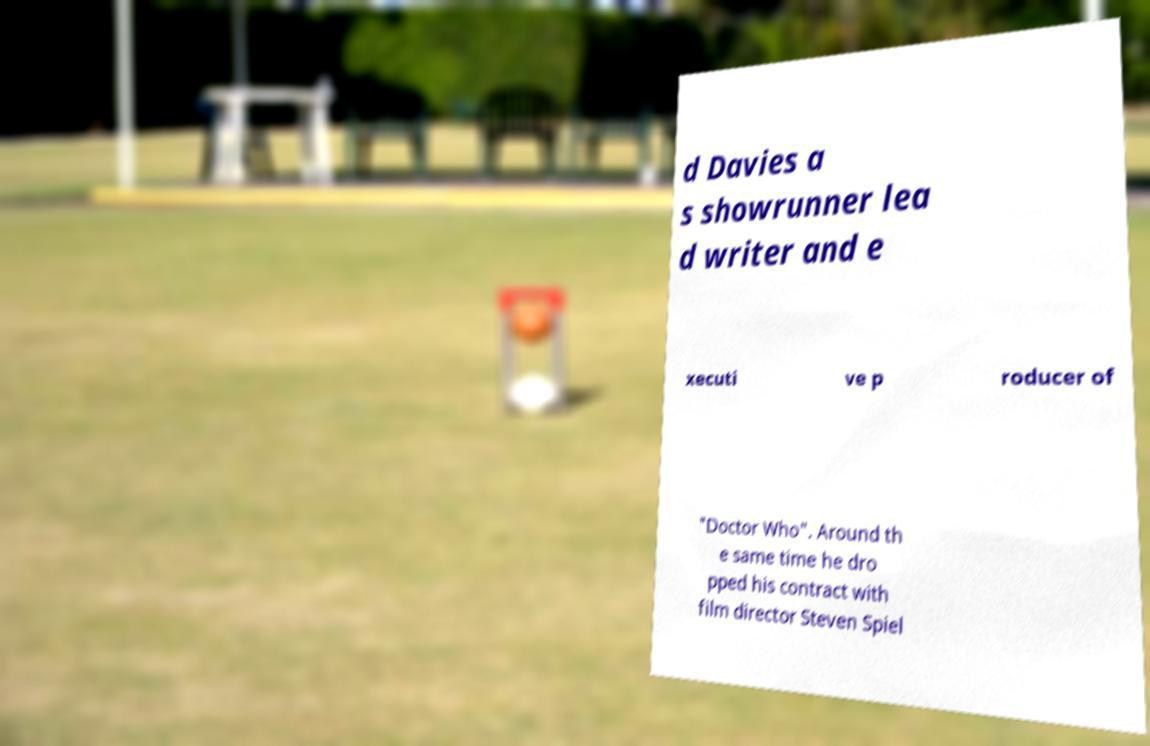There's text embedded in this image that I need extracted. Can you transcribe it verbatim? d Davies a s showrunner lea d writer and e xecuti ve p roducer of "Doctor Who". Around th e same time he dro pped his contract with film director Steven Spiel 